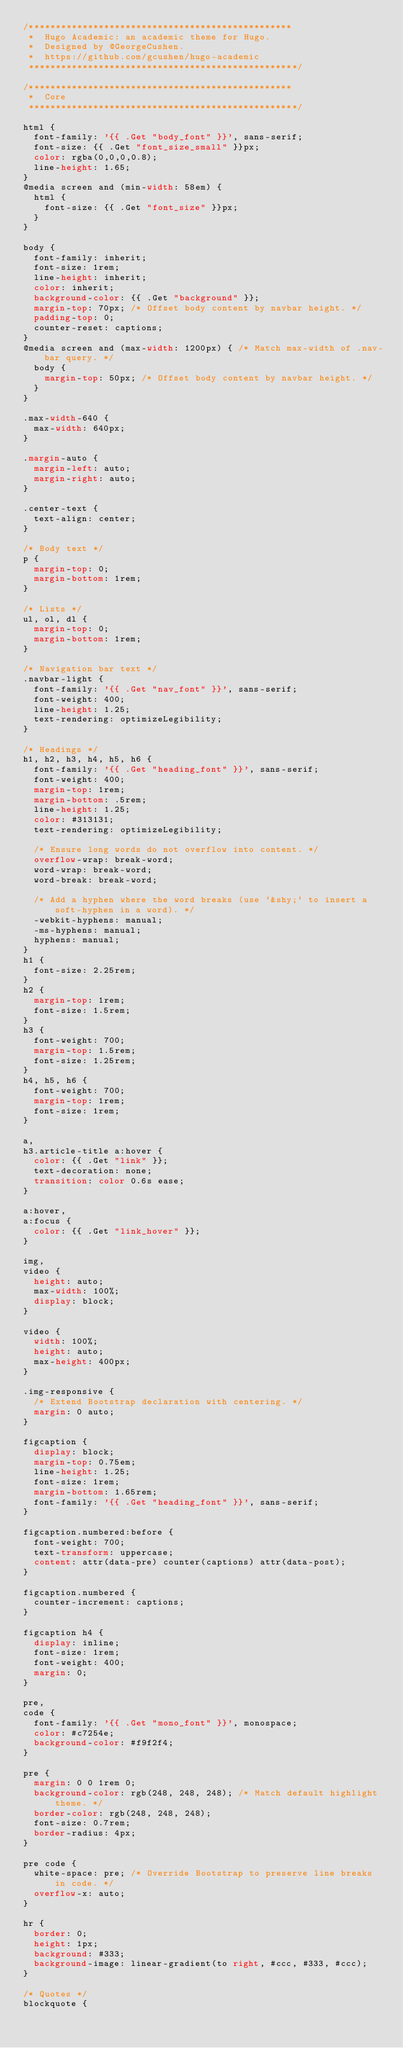<code> <loc_0><loc_0><loc_500><loc_500><_CSS_>/*************************************************
 *  Hugo Academic: an academic theme for Hugo.
 *  Designed by @GeorgeCushen.
 *  https://github.com/gcushen/hugo-academic
 **************************************************/

/*************************************************
 *  Core
 **************************************************/

html {
  font-family: '{{ .Get "body_font" }}', sans-serif;
  font-size: {{ .Get "font_size_small" }}px;
  color: rgba(0,0,0,0.8);
  line-height: 1.65;
}
@media screen and (min-width: 58em) {
  html {
    font-size: {{ .Get "font_size" }}px;
  }
}

body {
  font-family: inherit;
  font-size: 1rem;
  line-height: inherit;
  color: inherit;
  background-color: {{ .Get "background" }};
  margin-top: 70px; /* Offset body content by navbar height. */
  padding-top: 0;
  counter-reset: captions;
}
@media screen and (max-width: 1200px) { /* Match max-width of .nav-bar query. */
  body {
    margin-top: 50px; /* Offset body content by navbar height. */
  }
}

.max-width-640 {
  max-width: 640px;
}

.margin-auto {
  margin-left: auto;
  margin-right: auto;
}

.center-text {
  text-align: center;
}

/* Body text */
p {
  margin-top: 0;
  margin-bottom: 1rem;
}

/* Lists */
ul, ol, dl {
  margin-top: 0;
  margin-bottom: 1rem;
}

/* Navigation bar text */
.navbar-light {
  font-family: '{{ .Get "nav_font" }}', sans-serif;
  font-weight: 400;
  line-height: 1.25;
  text-rendering: optimizeLegibility;
}

/* Headings */
h1, h2, h3, h4, h5, h6 {
  font-family: '{{ .Get "heading_font" }}', sans-serif;
  font-weight: 400;
  margin-top: 1rem;
  margin-bottom: .5rem;
  line-height: 1.25;
  color: #313131;
  text-rendering: optimizeLegibility;

  /* Ensure long words do not overflow into content. */
  overflow-wrap: break-word;
  word-wrap: break-word;
  word-break: break-word;

  /* Add a hyphen where the word breaks (use `&shy;` to insert a soft-hyphen in a word). */
  -webkit-hyphens: manual;
  -ms-hyphens: manual;
  hyphens: manual;
}
h1 {
  font-size: 2.25rem;
}
h2 {
  margin-top: 1rem;
  font-size: 1.5rem;
}
h3 {
  font-weight: 700;
  margin-top: 1.5rem;
  font-size: 1.25rem;
}
h4, h5, h6 {
  font-weight: 700;
  margin-top: 1rem;
  font-size: 1rem;
}

a,
h3.article-title a:hover {
  color: {{ .Get "link" }};
  text-decoration: none;
  transition: color 0.6s ease;
}

a:hover,
a:focus {
  color: {{ .Get "link_hover" }};
}

img,
video {
  height: auto;
  max-width: 100%;
  display: block;
}

video {
  width: 100%;
  height: auto;
  max-height: 400px;
}

.img-responsive {
  /* Extend Bootstrap declaration with centering. */
  margin: 0 auto;
}

figcaption {
  display: block;
  margin-top: 0.75em;
  line-height: 1.25;
  font-size: 1rem;
  margin-bottom: 1.65rem;
  font-family: '{{ .Get "heading_font" }}', sans-serif;
}

figcaption.numbered:before {
  font-weight: 700;
  text-transform: uppercase;
  content: attr(data-pre) counter(captions) attr(data-post);
}

figcaption.numbered {
  counter-increment: captions;
}

figcaption h4 {
  display: inline;
  font-size: 1rem;
  font-weight: 400;
  margin: 0;
}

pre,
code {
  font-family: '{{ .Get "mono_font" }}', monospace;
  color: #c7254e;
  background-color: #f9f2f4;
}

pre {
  margin: 0 0 1rem 0;
  background-color: rgb(248, 248, 248); /* Match default highlight theme. */
  border-color: rgb(248, 248, 248);
  font-size: 0.7rem;
  border-radius: 4px;
}

pre code {
  white-space: pre; /* Override Bootstrap to preserve line breaks in code. */
  overflow-x: auto;
}

hr {
  border: 0;
  height: 1px;
  background: #333;
  background-image: linear-gradient(to right, #ccc, #333, #ccc);
}

/* Quotes */
blockquote {</code> 